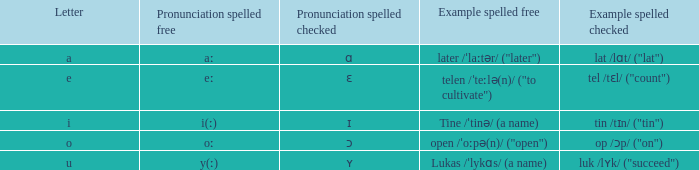Give me the full table as a dictionary. {'header': ['Letter', 'Pronunciation spelled free', 'Pronunciation spelled checked', 'Example spelled free', 'Example spelled checked'], 'rows': [['a', 'aː', 'ɑ', 'later /ˈlaːtər/ ("later")', 'lat /lɑt/ ("lat")'], ['e', 'eː', 'ɛ', 'telen /ˈteːlə(n)/ ("to cultivate")', 'tel /tɛl/ ("count")'], ['i', 'i(ː)', 'ɪ', 'Tine /ˈtinə/ (a name)', 'tin /tɪn/ ("tin")'], ['o', 'oː', 'ɔ', 'open /ˈoːpə(n)/ ("open")', 'op /ɔp/ ("on")'], ['u', 'y(ː)', 'ʏ', 'Lukas /ˈlykɑs/ (a name)', 'luk /lʏk/ ("succeed")']]} What is example spelled unrestricted, when example spelled examined is "op /ɔp/ ('on')"? Open /ˈoːpə(n)/ ("open"). 